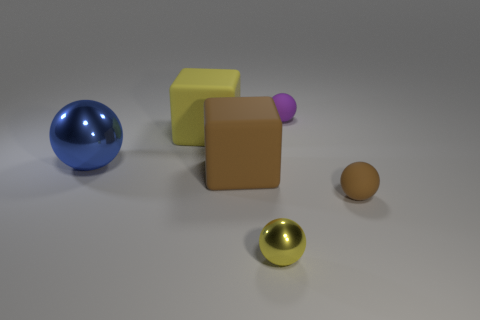What size is the metallic object in front of the brown ball?
Your answer should be compact. Small. There is a shiny thing that is on the left side of the tiny yellow metallic sphere; what number of brown matte spheres are behind it?
Ensure brevity in your answer.  0. How many other objects are the same size as the purple rubber ball?
Offer a terse response. 2. There is a brown object that is on the right side of the tiny yellow thing; is its shape the same as the big yellow thing?
Make the answer very short. No. How many objects are both to the right of the big shiny ball and on the left side of the big brown thing?
Your answer should be compact. 1. What is the big yellow cube made of?
Offer a terse response. Rubber. Are there any other things of the same color as the small shiny thing?
Make the answer very short. Yes. Does the small brown object have the same material as the tiny yellow ball?
Offer a terse response. No. There is a large yellow rubber block that is to the left of the matte block in front of the large blue metallic sphere; how many large rubber blocks are in front of it?
Give a very brief answer. 1. How many large brown cubes are there?
Your response must be concise. 1. 